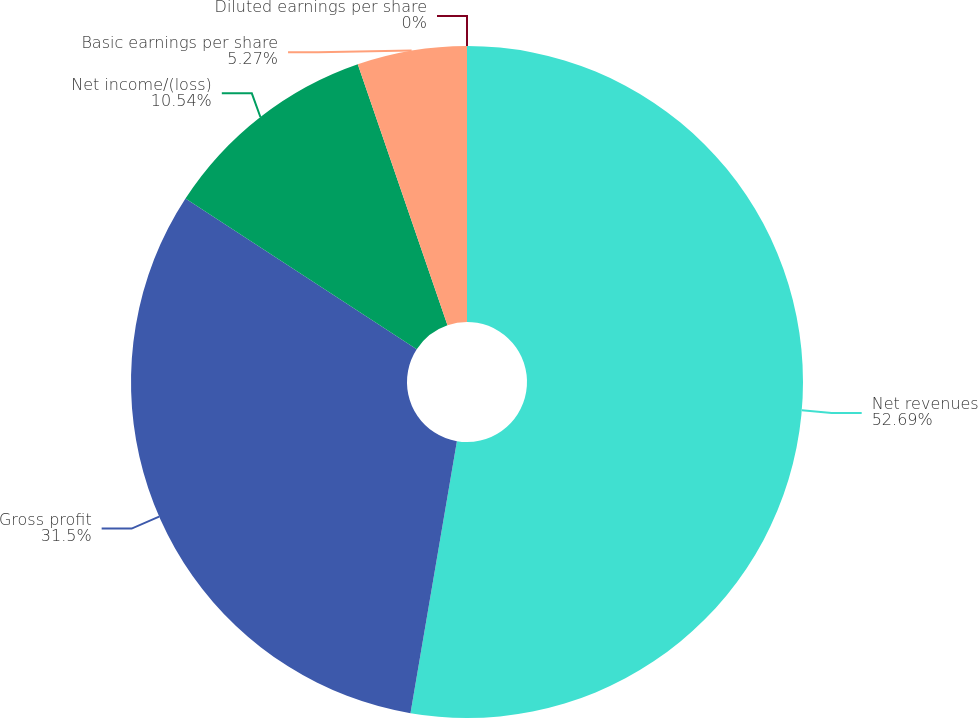Convert chart to OTSL. <chart><loc_0><loc_0><loc_500><loc_500><pie_chart><fcel>Net revenues<fcel>Gross profit<fcel>Net income/(loss)<fcel>Basic earnings per share<fcel>Diluted earnings per share<nl><fcel>52.69%<fcel>31.5%<fcel>10.54%<fcel>5.27%<fcel>0.0%<nl></chart> 